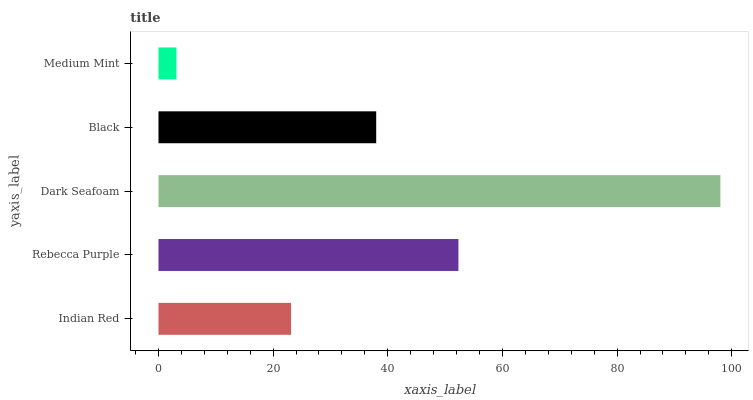Is Medium Mint the minimum?
Answer yes or no. Yes. Is Dark Seafoam the maximum?
Answer yes or no. Yes. Is Rebecca Purple the minimum?
Answer yes or no. No. Is Rebecca Purple the maximum?
Answer yes or no. No. Is Rebecca Purple greater than Indian Red?
Answer yes or no. Yes. Is Indian Red less than Rebecca Purple?
Answer yes or no. Yes. Is Indian Red greater than Rebecca Purple?
Answer yes or no. No. Is Rebecca Purple less than Indian Red?
Answer yes or no. No. Is Black the high median?
Answer yes or no. Yes. Is Black the low median?
Answer yes or no. Yes. Is Indian Red the high median?
Answer yes or no. No. Is Dark Seafoam the low median?
Answer yes or no. No. 